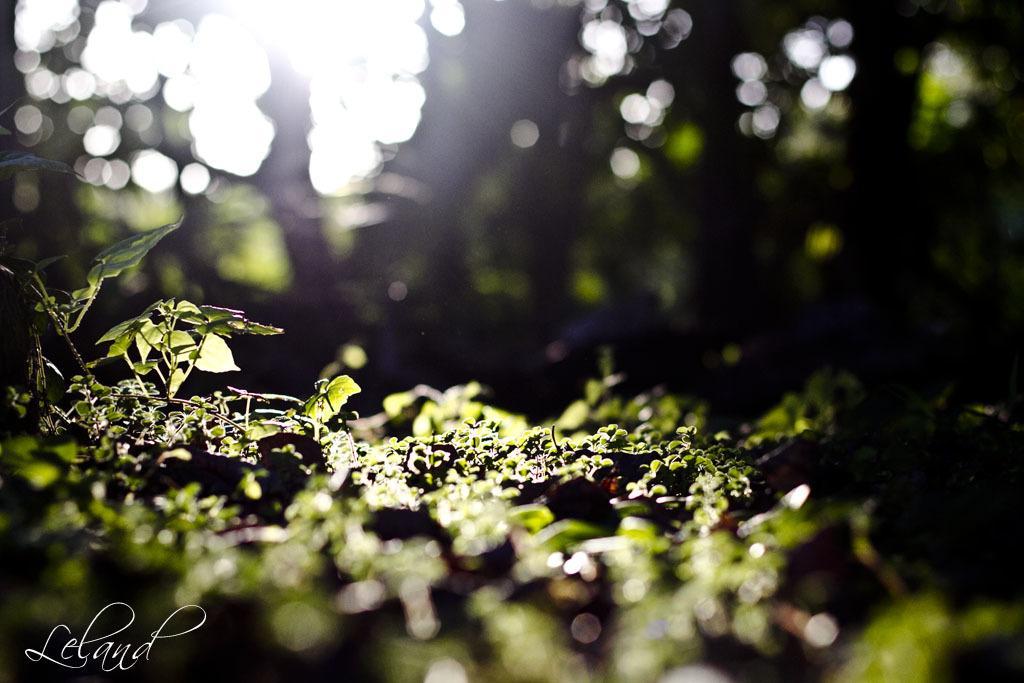How would you summarize this image in a sentence or two? This is the picture of a place where we have some plants. 